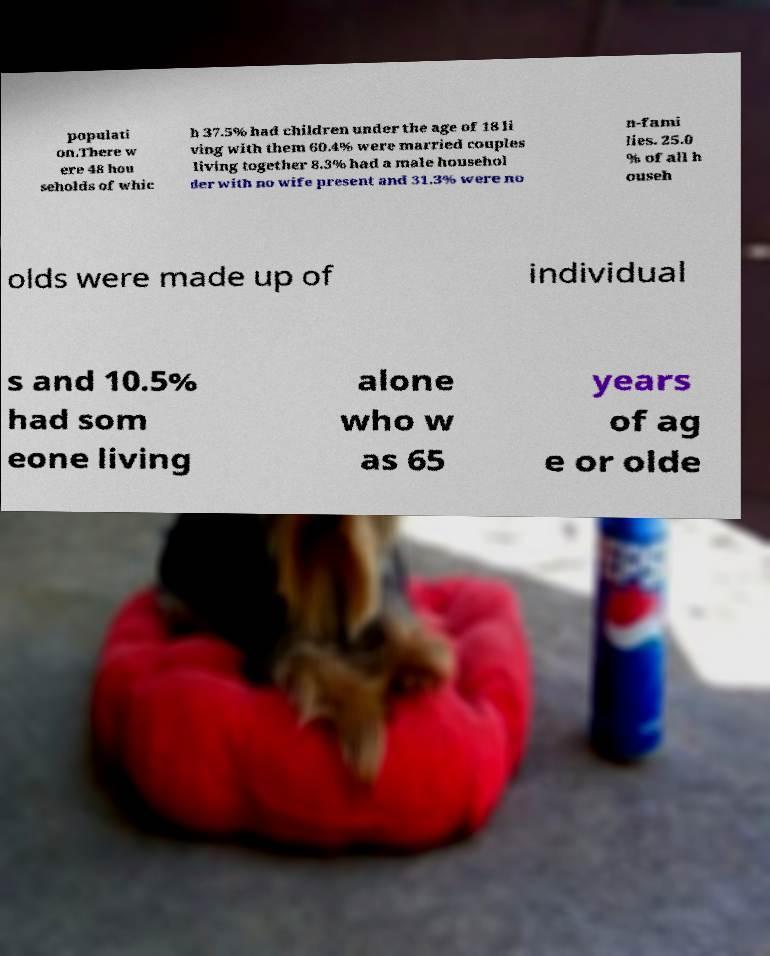Please read and relay the text visible in this image. What does it say? populati on.There w ere 48 hou seholds of whic h 37.5% had children under the age of 18 li ving with them 60.4% were married couples living together 8.3% had a male househol der with no wife present and 31.3% were no n-fami lies. 25.0 % of all h ouseh olds were made up of individual s and 10.5% had som eone living alone who w as 65 years of ag e or olde 